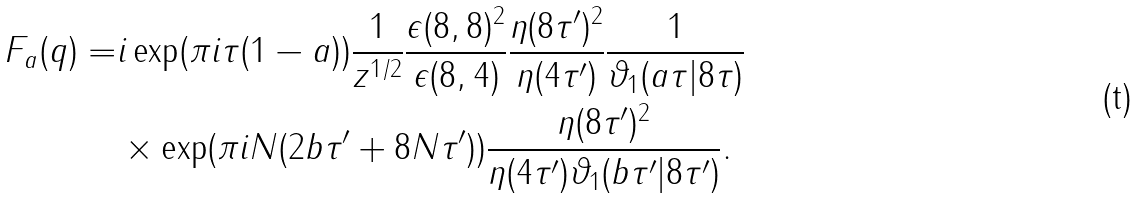<formula> <loc_0><loc_0><loc_500><loc_500>F _ { a } ( q ) = & i \exp ( \pi i \tau ( 1 - a ) ) \frac { 1 } { z ^ { 1 / 2 } } \frac { \epsilon ( 8 , 8 ) ^ { 2 } } { \epsilon ( 8 , 4 ) } \frac { \eta ( 8 \tau ^ { \prime } ) ^ { 2 } } { \eta ( 4 \tau ^ { \prime } ) } \frac { 1 } { \vartheta _ { 1 } ( a \tau | 8 \tau ) } \\ & \times \exp ( \pi i N ( 2 b \tau ^ { \prime } + 8 N \tau ^ { \prime } ) ) \frac { \eta ( 8 \tau ^ { \prime } ) ^ { 2 } } { \eta ( 4 \tau ^ { \prime } ) \vartheta _ { 1 } ( b \tau ^ { \prime } | 8 \tau ^ { \prime } ) } .</formula> 